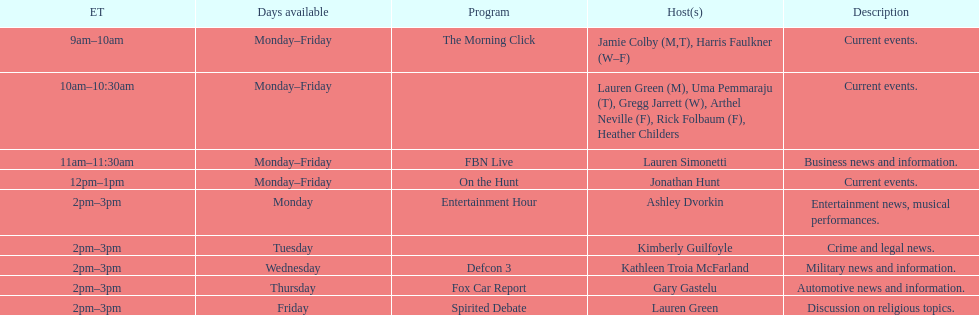What is the number of days per week that the fbn live show is aired? 5. 